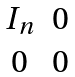<formula> <loc_0><loc_0><loc_500><loc_500>\begin{matrix} I _ { n } & 0 \\ 0 & 0 \end{matrix}</formula> 